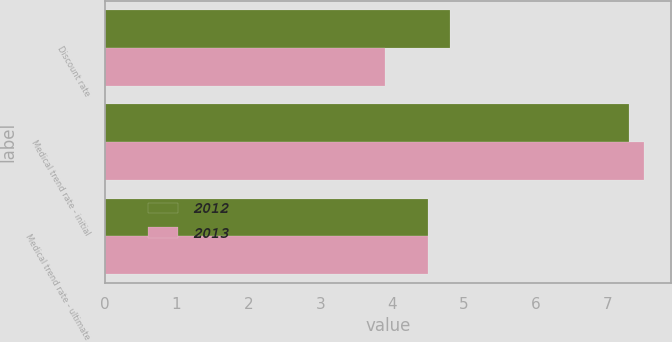<chart> <loc_0><loc_0><loc_500><loc_500><stacked_bar_chart><ecel><fcel>Discount rate<fcel>Medical trend rate - initial<fcel>Medical trend rate - ultimate<nl><fcel>2012<fcel>4.8<fcel>7.3<fcel>4.5<nl><fcel>2013<fcel>3.9<fcel>7.5<fcel>4.5<nl></chart> 